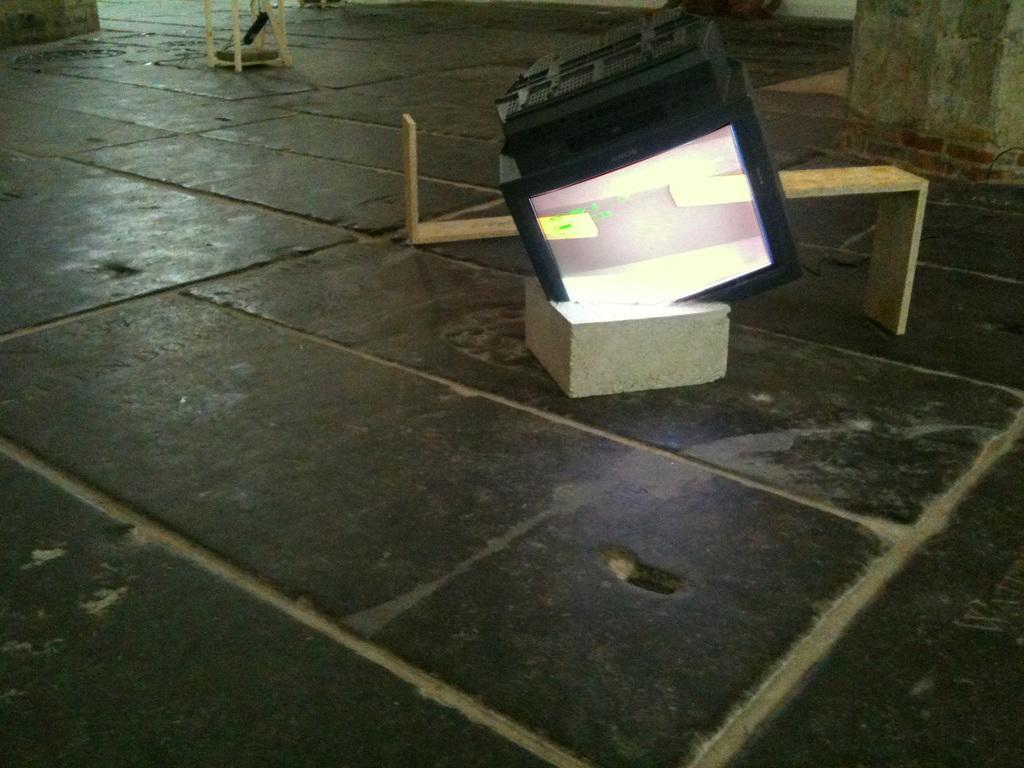What is the surface that can be seen in the image? There is a floor in the image. What object is placed on the floor? There is a box on the floor. What is placed on top of the box? There is a monitor on the box. What type of material can be seen in the background of the image? There are wooden sticks in the background of the image. What architectural features are visible in the background of the image? There are pillars in the background of the image. Can you tell me how many friends are visible in the image? There are no friends present in the image. Is there a person wearing a sweater in the image? There is no person or sweater visible in the image. 